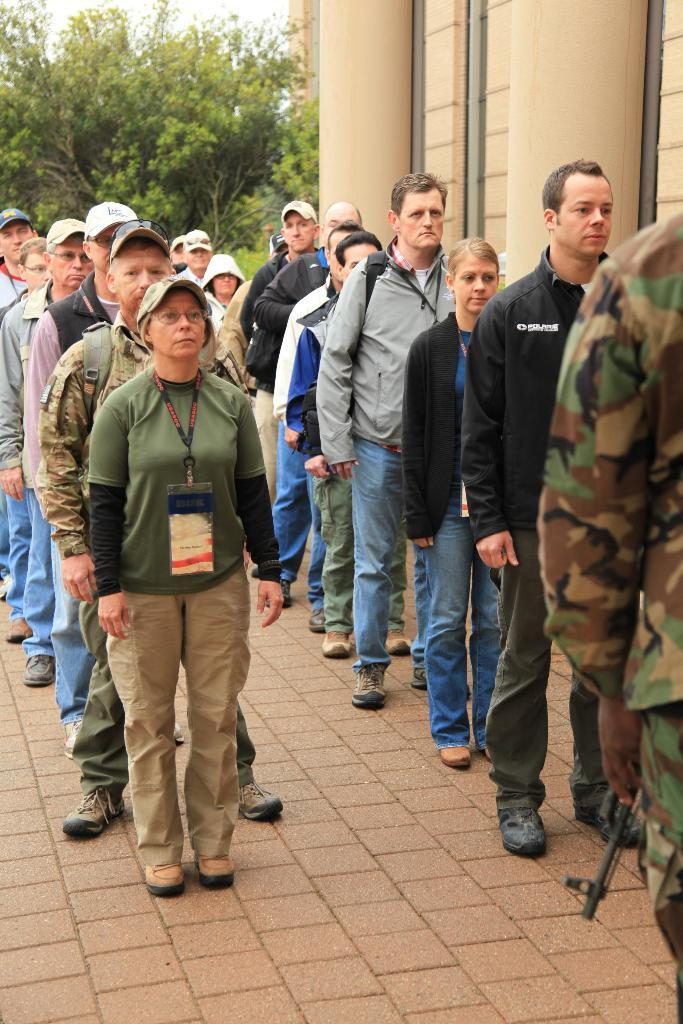How many people are in the image? There is a group of people in the image. Where are the people located in the image? The people are standing on a path. What is the person holding in the image? There is a person holding a gun in the image. What can be seen in the background of the image? There are trees, a building, and the sky visible in the background of the image. What is the reaction of the hands to the volcano in the image? There is no volcano present in the image, so it is not possible to determine the reaction of the hands. 